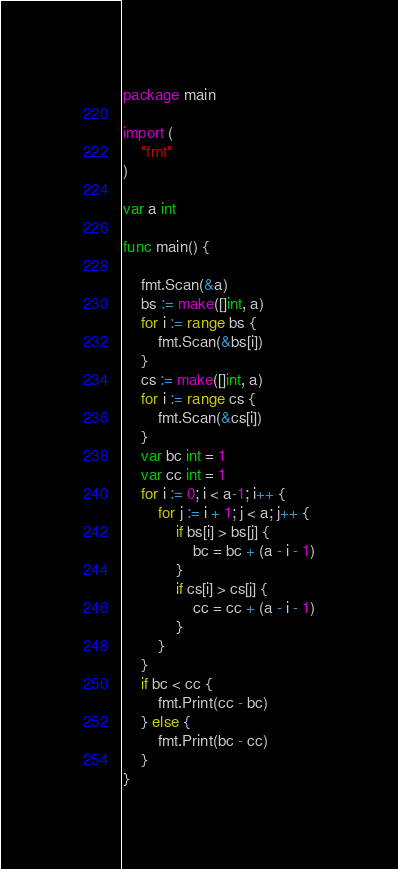Convert code to text. <code><loc_0><loc_0><loc_500><loc_500><_Go_>package main

import (
	"fmt"
)

var a int

func main() {

	fmt.Scan(&a)
	bs := make([]int, a)
	for i := range bs {
		fmt.Scan(&bs[i])
	}
	cs := make([]int, a)
	for i := range cs {
		fmt.Scan(&cs[i])
	}
	var bc int = 1
	var cc int = 1
	for i := 0; i < a-1; i++ {
		for j := i + 1; j < a; j++ {
			if bs[i] > bs[j] {
				bc = bc + (a - i - 1)
			}
			if cs[i] > cs[j] {
				cc = cc + (a - i - 1)
			}
		}
	}
	if bc < cc {
		fmt.Print(cc - bc)
	} else {
		fmt.Print(bc - cc)
	}
}
</code> 